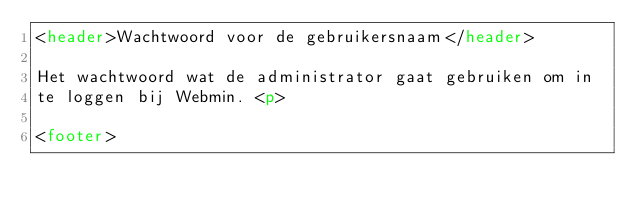Convert code to text. <code><loc_0><loc_0><loc_500><loc_500><_HTML_><header>Wachtwoord voor de gebruikersnaam</header>

Het wachtwoord wat de administrator gaat gebruiken om in
te loggen bij Webmin. <p>

<footer></code> 